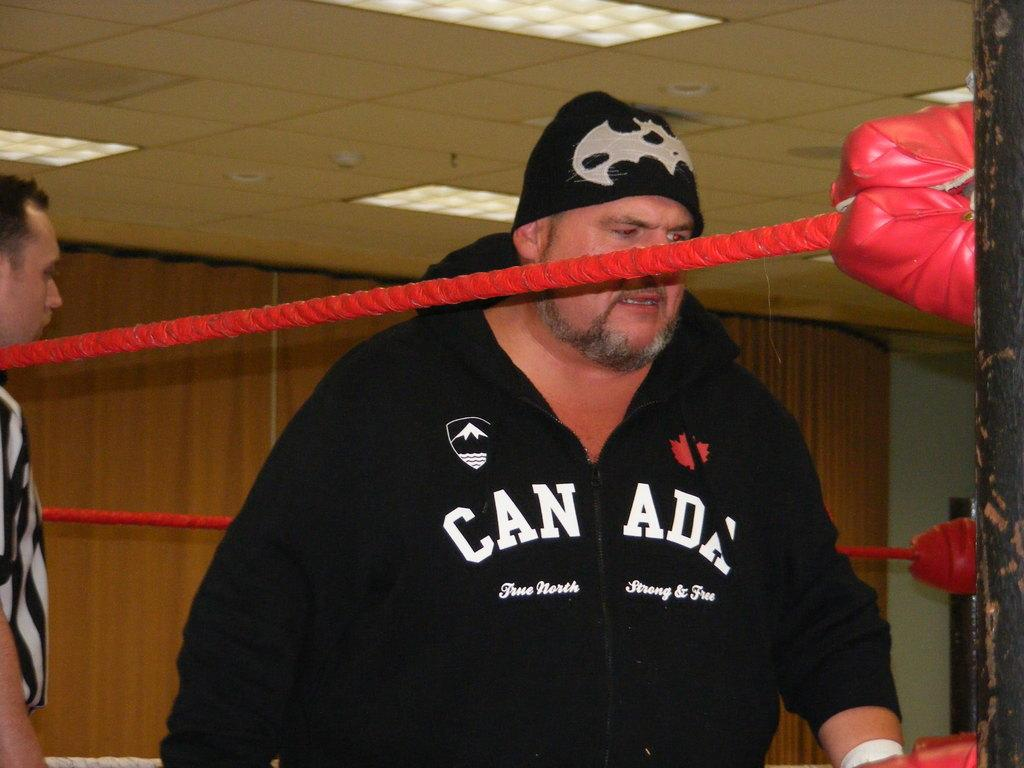<image>
Write a terse but informative summary of the picture. A man in a boxing ring wearing a jacket with the word Canada written on it. 